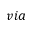<formula> <loc_0><loc_0><loc_500><loc_500>v i a</formula> 